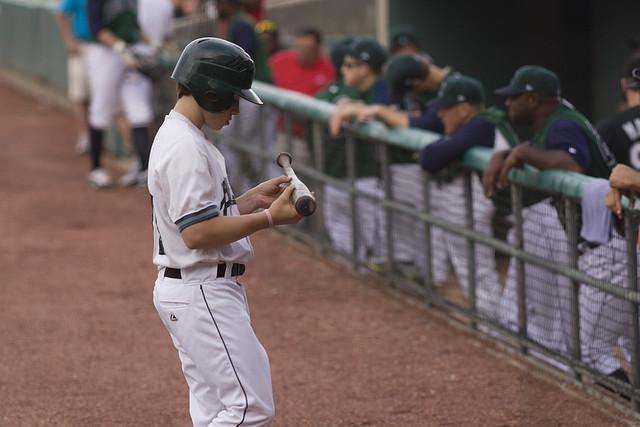What is the young man holding? bat 